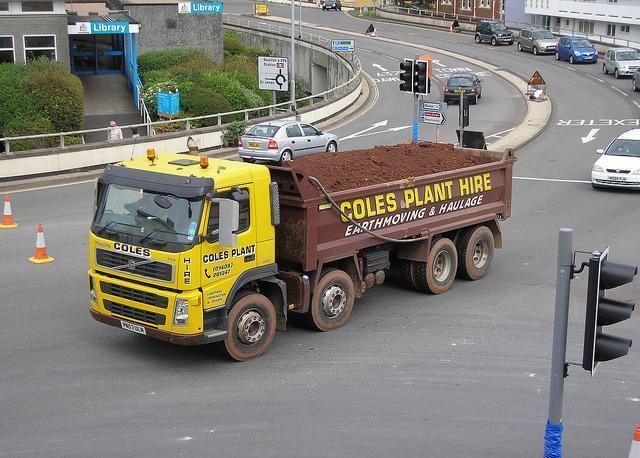How many cars are in the picture?
Give a very brief answer. 2. 